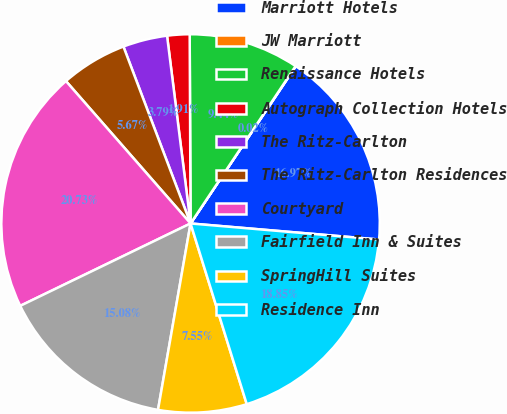Convert chart to OTSL. <chart><loc_0><loc_0><loc_500><loc_500><pie_chart><fcel>Marriott Hotels<fcel>JW Marriott<fcel>Renaissance Hotels<fcel>Autograph Collection Hotels<fcel>The Ritz-Carlton<fcel>The Ritz-Carlton Residences<fcel>Courtyard<fcel>Fairfield Inn & Suites<fcel>SpringHill Suites<fcel>Residence Inn<nl><fcel>16.97%<fcel>0.02%<fcel>9.44%<fcel>1.91%<fcel>3.79%<fcel>5.67%<fcel>20.73%<fcel>15.08%<fcel>7.55%<fcel>18.85%<nl></chart> 